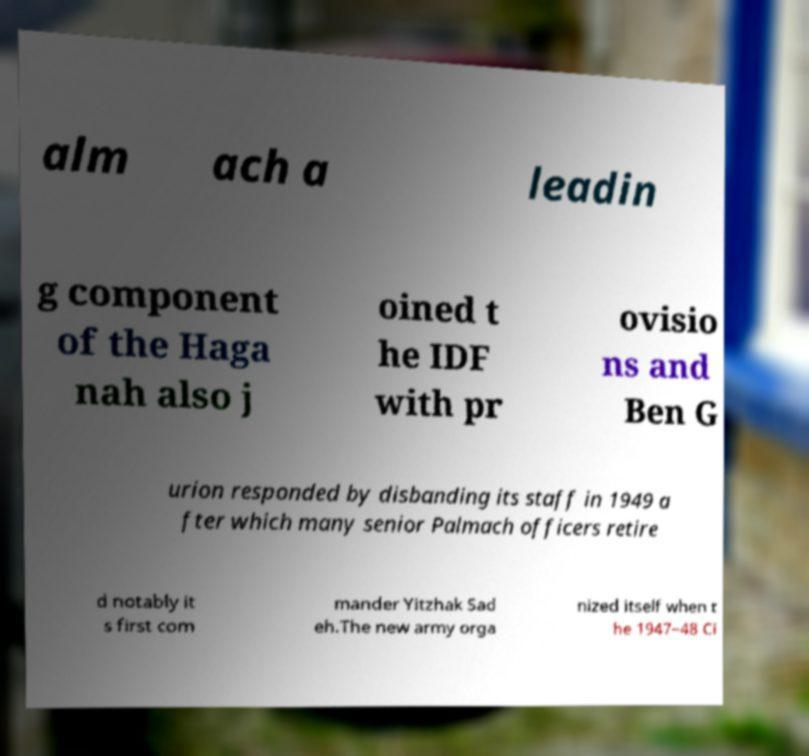What messages or text are displayed in this image? I need them in a readable, typed format. alm ach a leadin g component of the Haga nah also j oined t he IDF with pr ovisio ns and Ben G urion responded by disbanding its staff in 1949 a fter which many senior Palmach officers retire d notably it s first com mander Yitzhak Sad eh.The new army orga nized itself when t he 1947–48 Ci 